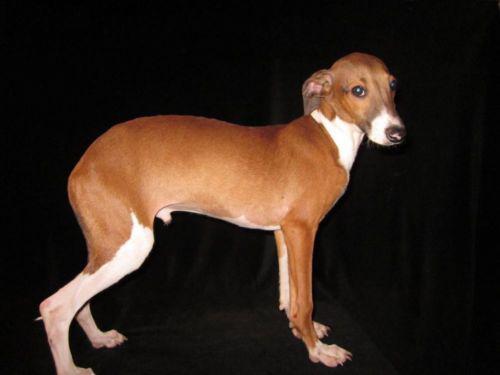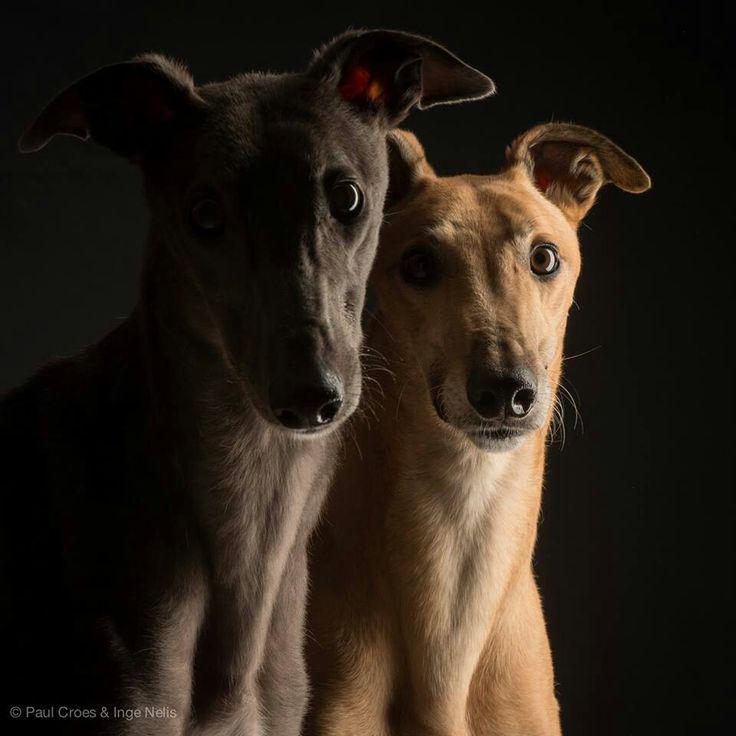The first image is the image on the left, the second image is the image on the right. Examine the images to the left and right. Is the description "The dog on the right image is facing left." accurate? Answer yes or no. No. 